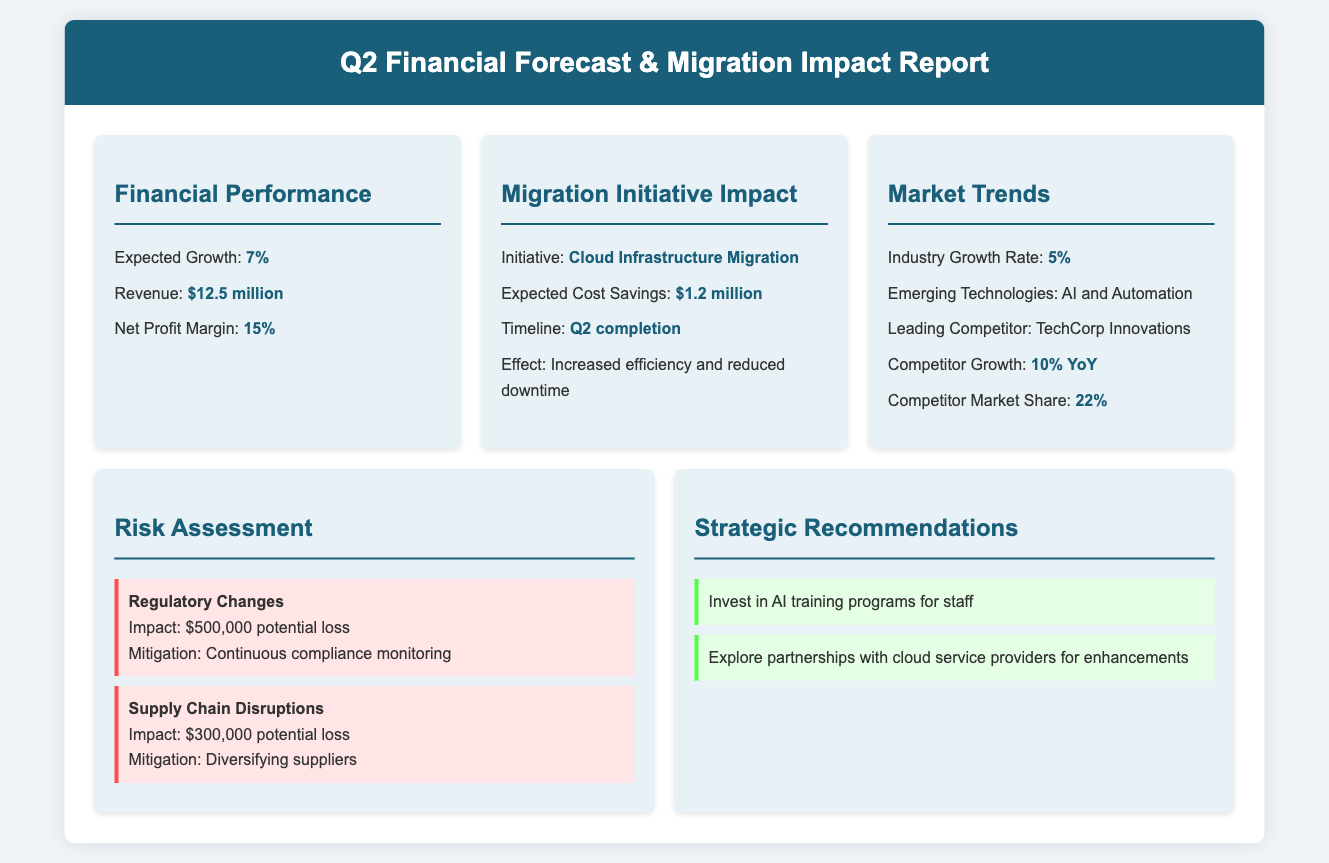What is the expected growth for Q2? The expected growth percentage mentioned in the financial performance section is 7%.
Answer: 7% What is the expected revenue for the upcoming quarter? The revenue forecast for the upcoming quarter is specified as $12.5 million.
Answer: $12.5 million What initiative is discussed in the Migration Initiative Impact section? The initiative mentioned is the "Cloud Infrastructure Migration."
Answer: Cloud Infrastructure Migration How much cost savings are expected from the migration initiatives? The expected cost savings from the migration initiatives are listed as $1.2 million.
Answer: $1.2 million What is the Industry Growth Rate according to the Market Trends section? The industry growth rate presented in the document is 5%.
Answer: 5% Which competitor is identified as leading in the market? The leading competitor specified is "TechCorp Innovations."
Answer: TechCorp Innovations What is the potential financial impact of regulatory changes? The document states that the potential loss from regulatory changes is $500,000.
Answer: $500,000 What strategic recommendation is made regarding AI? One of the strategic recommendations is to "Invest in AI training programs for staff."
Answer: Invest in AI training programs for staff What mitigation strategy is suggested for supply chain disruptions? The document recommends "Diversifying suppliers" as a mitigation strategy for supply chain disruptions.
Answer: Diversifying suppliers 